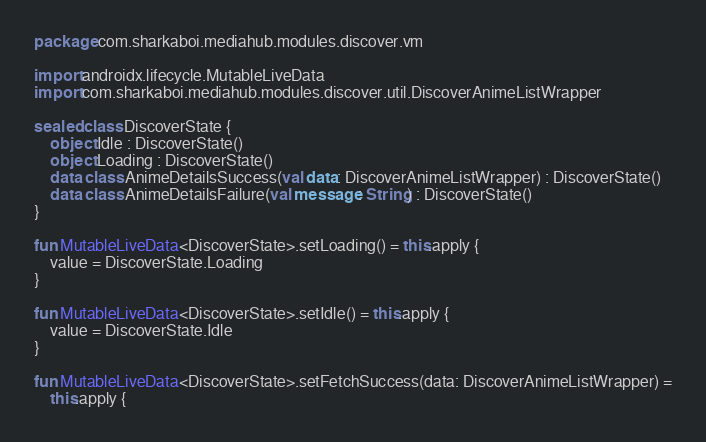Convert code to text. <code><loc_0><loc_0><loc_500><loc_500><_Kotlin_>package com.sharkaboi.mediahub.modules.discover.vm

import androidx.lifecycle.MutableLiveData
import com.sharkaboi.mediahub.modules.discover.util.DiscoverAnimeListWrapper

sealed class DiscoverState {
    object Idle : DiscoverState()
    object Loading : DiscoverState()
    data class AnimeDetailsSuccess(val data: DiscoverAnimeListWrapper) : DiscoverState()
    data class AnimeDetailsFailure(val message: String) : DiscoverState()
}

fun MutableLiveData<DiscoverState>.setLoading() = this.apply {
    value = DiscoverState.Loading
}

fun MutableLiveData<DiscoverState>.setIdle() = this.apply {
    value = DiscoverState.Idle
}

fun MutableLiveData<DiscoverState>.setFetchSuccess(data: DiscoverAnimeListWrapper) =
    this.apply {</code> 